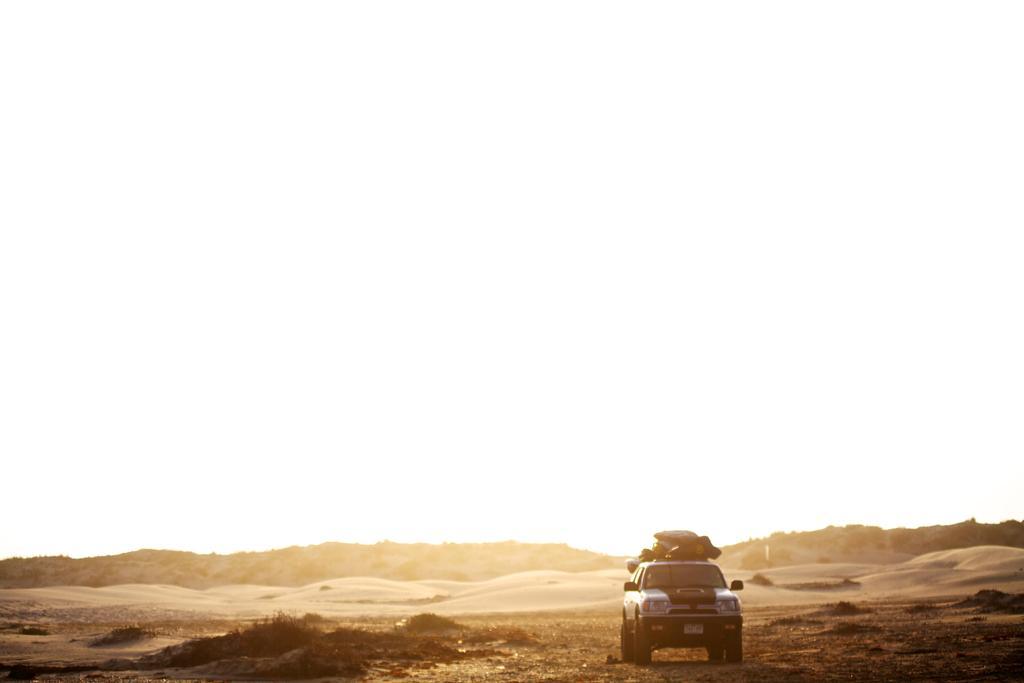Please provide a concise description of this image. At the bottom of the image we can see vehicle, sand, grass and trees. In the background there is sky. 